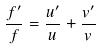Convert formula to latex. <formula><loc_0><loc_0><loc_500><loc_500>\frac { f ^ { \prime } } { f } = \frac { u ^ { \prime } } { u } + \frac { v ^ { \prime } } { v }</formula> 